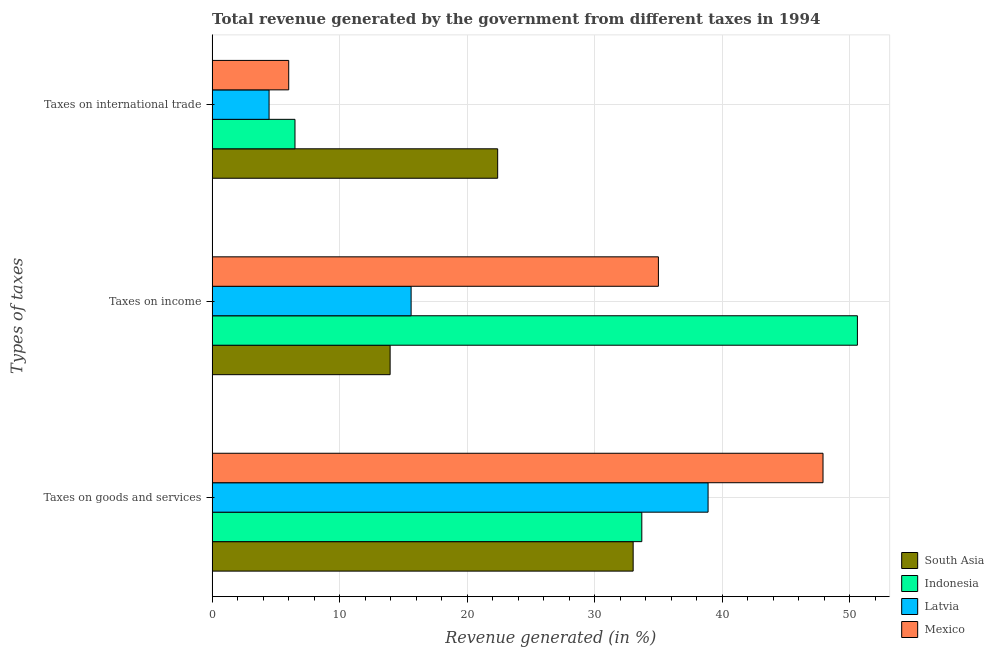How many different coloured bars are there?
Offer a very short reply. 4. How many bars are there on the 3rd tick from the top?
Your answer should be very brief. 4. What is the label of the 1st group of bars from the top?
Provide a succinct answer. Taxes on international trade. What is the percentage of revenue generated by tax on international trade in Latvia?
Make the answer very short. 4.46. Across all countries, what is the maximum percentage of revenue generated by tax on international trade?
Make the answer very short. 22.39. Across all countries, what is the minimum percentage of revenue generated by tax on international trade?
Keep it short and to the point. 4.46. In which country was the percentage of revenue generated by tax on international trade minimum?
Your response must be concise. Latvia. What is the total percentage of revenue generated by taxes on goods and services in the graph?
Keep it short and to the point. 153.46. What is the difference between the percentage of revenue generated by taxes on goods and services in Latvia and that in Indonesia?
Your response must be concise. 5.19. What is the difference between the percentage of revenue generated by taxes on income in Mexico and the percentage of revenue generated by taxes on goods and services in Latvia?
Your answer should be compact. -3.89. What is the average percentage of revenue generated by tax on international trade per country?
Your answer should be very brief. 9.84. What is the difference between the percentage of revenue generated by taxes on goods and services and percentage of revenue generated by taxes on income in Indonesia?
Give a very brief answer. -16.9. In how many countries, is the percentage of revenue generated by taxes on goods and services greater than 40 %?
Ensure brevity in your answer.  1. What is the ratio of the percentage of revenue generated by tax on international trade in Indonesia to that in Mexico?
Keep it short and to the point. 1.08. Is the percentage of revenue generated by tax on international trade in Latvia less than that in Mexico?
Offer a very short reply. Yes. Is the difference between the percentage of revenue generated by taxes on income in Latvia and South Asia greater than the difference between the percentage of revenue generated by taxes on goods and services in Latvia and South Asia?
Keep it short and to the point. No. What is the difference between the highest and the second highest percentage of revenue generated by tax on international trade?
Your answer should be very brief. 15.89. What is the difference between the highest and the lowest percentage of revenue generated by taxes on goods and services?
Ensure brevity in your answer.  14.88. In how many countries, is the percentage of revenue generated by taxes on income greater than the average percentage of revenue generated by taxes on income taken over all countries?
Provide a short and direct response. 2. What does the 3rd bar from the top in Taxes on international trade represents?
Provide a short and direct response. Indonesia. How many bars are there?
Your answer should be compact. 12. Are all the bars in the graph horizontal?
Your answer should be compact. Yes. How many countries are there in the graph?
Your answer should be very brief. 4. What is the difference between two consecutive major ticks on the X-axis?
Offer a terse response. 10. Are the values on the major ticks of X-axis written in scientific E-notation?
Offer a very short reply. No. Does the graph contain any zero values?
Ensure brevity in your answer.  No. Does the graph contain grids?
Your answer should be very brief. Yes. Where does the legend appear in the graph?
Your answer should be compact. Bottom right. How are the legend labels stacked?
Provide a succinct answer. Vertical. What is the title of the graph?
Your answer should be very brief. Total revenue generated by the government from different taxes in 1994. Does "Lower middle income" appear as one of the legend labels in the graph?
Ensure brevity in your answer.  No. What is the label or title of the X-axis?
Keep it short and to the point. Revenue generated (in %). What is the label or title of the Y-axis?
Ensure brevity in your answer.  Types of taxes. What is the Revenue generated (in %) in South Asia in Taxes on goods and services?
Your answer should be very brief. 33.01. What is the Revenue generated (in %) of Indonesia in Taxes on goods and services?
Provide a succinct answer. 33.68. What is the Revenue generated (in %) in Latvia in Taxes on goods and services?
Your answer should be compact. 38.88. What is the Revenue generated (in %) in Mexico in Taxes on goods and services?
Provide a short and direct response. 47.89. What is the Revenue generated (in %) in South Asia in Taxes on income?
Your answer should be compact. 13.95. What is the Revenue generated (in %) in Indonesia in Taxes on income?
Give a very brief answer. 50.58. What is the Revenue generated (in %) of Latvia in Taxes on income?
Your answer should be compact. 15.6. What is the Revenue generated (in %) of Mexico in Taxes on income?
Your answer should be very brief. 34.98. What is the Revenue generated (in %) of South Asia in Taxes on international trade?
Offer a very short reply. 22.39. What is the Revenue generated (in %) in Indonesia in Taxes on international trade?
Keep it short and to the point. 6.5. What is the Revenue generated (in %) of Latvia in Taxes on international trade?
Your answer should be compact. 4.46. What is the Revenue generated (in %) in Mexico in Taxes on international trade?
Ensure brevity in your answer.  6. Across all Types of taxes, what is the maximum Revenue generated (in %) in South Asia?
Offer a very short reply. 33.01. Across all Types of taxes, what is the maximum Revenue generated (in %) of Indonesia?
Provide a succinct answer. 50.58. Across all Types of taxes, what is the maximum Revenue generated (in %) in Latvia?
Ensure brevity in your answer.  38.88. Across all Types of taxes, what is the maximum Revenue generated (in %) of Mexico?
Your response must be concise. 47.89. Across all Types of taxes, what is the minimum Revenue generated (in %) in South Asia?
Give a very brief answer. 13.95. Across all Types of taxes, what is the minimum Revenue generated (in %) of Indonesia?
Your answer should be compact. 6.5. Across all Types of taxes, what is the minimum Revenue generated (in %) in Latvia?
Your response must be concise. 4.46. Across all Types of taxes, what is the minimum Revenue generated (in %) in Mexico?
Your answer should be very brief. 6. What is the total Revenue generated (in %) in South Asia in the graph?
Make the answer very short. 69.34. What is the total Revenue generated (in %) of Indonesia in the graph?
Your response must be concise. 90.76. What is the total Revenue generated (in %) in Latvia in the graph?
Provide a succinct answer. 58.94. What is the total Revenue generated (in %) in Mexico in the graph?
Keep it short and to the point. 88.88. What is the difference between the Revenue generated (in %) of South Asia in Taxes on goods and services and that in Taxes on income?
Your answer should be compact. 19.05. What is the difference between the Revenue generated (in %) of Indonesia in Taxes on goods and services and that in Taxes on income?
Make the answer very short. -16.9. What is the difference between the Revenue generated (in %) of Latvia in Taxes on goods and services and that in Taxes on income?
Ensure brevity in your answer.  23.28. What is the difference between the Revenue generated (in %) in Mexico in Taxes on goods and services and that in Taxes on income?
Keep it short and to the point. 12.9. What is the difference between the Revenue generated (in %) of South Asia in Taxes on goods and services and that in Taxes on international trade?
Make the answer very short. 10.62. What is the difference between the Revenue generated (in %) of Indonesia in Taxes on goods and services and that in Taxes on international trade?
Your answer should be very brief. 27.19. What is the difference between the Revenue generated (in %) in Latvia in Taxes on goods and services and that in Taxes on international trade?
Provide a short and direct response. 34.41. What is the difference between the Revenue generated (in %) of Mexico in Taxes on goods and services and that in Taxes on international trade?
Your response must be concise. 41.88. What is the difference between the Revenue generated (in %) of South Asia in Taxes on income and that in Taxes on international trade?
Make the answer very short. -8.43. What is the difference between the Revenue generated (in %) of Indonesia in Taxes on income and that in Taxes on international trade?
Your response must be concise. 44.09. What is the difference between the Revenue generated (in %) of Latvia in Taxes on income and that in Taxes on international trade?
Your answer should be very brief. 11.14. What is the difference between the Revenue generated (in %) of Mexico in Taxes on income and that in Taxes on international trade?
Give a very brief answer. 28.98. What is the difference between the Revenue generated (in %) in South Asia in Taxes on goods and services and the Revenue generated (in %) in Indonesia in Taxes on income?
Ensure brevity in your answer.  -17.58. What is the difference between the Revenue generated (in %) in South Asia in Taxes on goods and services and the Revenue generated (in %) in Latvia in Taxes on income?
Provide a succinct answer. 17.41. What is the difference between the Revenue generated (in %) in South Asia in Taxes on goods and services and the Revenue generated (in %) in Mexico in Taxes on income?
Your answer should be very brief. -1.98. What is the difference between the Revenue generated (in %) of Indonesia in Taxes on goods and services and the Revenue generated (in %) of Latvia in Taxes on income?
Your answer should be compact. 18.09. What is the difference between the Revenue generated (in %) of Indonesia in Taxes on goods and services and the Revenue generated (in %) of Mexico in Taxes on income?
Provide a succinct answer. -1.3. What is the difference between the Revenue generated (in %) of Latvia in Taxes on goods and services and the Revenue generated (in %) of Mexico in Taxes on income?
Provide a succinct answer. 3.89. What is the difference between the Revenue generated (in %) of South Asia in Taxes on goods and services and the Revenue generated (in %) of Indonesia in Taxes on international trade?
Make the answer very short. 26.51. What is the difference between the Revenue generated (in %) in South Asia in Taxes on goods and services and the Revenue generated (in %) in Latvia in Taxes on international trade?
Give a very brief answer. 28.54. What is the difference between the Revenue generated (in %) of South Asia in Taxes on goods and services and the Revenue generated (in %) of Mexico in Taxes on international trade?
Offer a terse response. 27. What is the difference between the Revenue generated (in %) of Indonesia in Taxes on goods and services and the Revenue generated (in %) of Latvia in Taxes on international trade?
Your answer should be compact. 29.22. What is the difference between the Revenue generated (in %) in Indonesia in Taxes on goods and services and the Revenue generated (in %) in Mexico in Taxes on international trade?
Give a very brief answer. 27.68. What is the difference between the Revenue generated (in %) of Latvia in Taxes on goods and services and the Revenue generated (in %) of Mexico in Taxes on international trade?
Give a very brief answer. 32.87. What is the difference between the Revenue generated (in %) in South Asia in Taxes on income and the Revenue generated (in %) in Indonesia in Taxes on international trade?
Make the answer very short. 7.46. What is the difference between the Revenue generated (in %) in South Asia in Taxes on income and the Revenue generated (in %) in Latvia in Taxes on international trade?
Your response must be concise. 9.49. What is the difference between the Revenue generated (in %) of South Asia in Taxes on income and the Revenue generated (in %) of Mexico in Taxes on international trade?
Give a very brief answer. 7.95. What is the difference between the Revenue generated (in %) in Indonesia in Taxes on income and the Revenue generated (in %) in Latvia in Taxes on international trade?
Keep it short and to the point. 46.12. What is the difference between the Revenue generated (in %) in Indonesia in Taxes on income and the Revenue generated (in %) in Mexico in Taxes on international trade?
Your answer should be compact. 44.58. What is the difference between the Revenue generated (in %) in Latvia in Taxes on income and the Revenue generated (in %) in Mexico in Taxes on international trade?
Your answer should be very brief. 9.59. What is the average Revenue generated (in %) of South Asia per Types of taxes?
Offer a very short reply. 23.11. What is the average Revenue generated (in %) of Indonesia per Types of taxes?
Give a very brief answer. 30.25. What is the average Revenue generated (in %) of Latvia per Types of taxes?
Offer a terse response. 19.65. What is the average Revenue generated (in %) in Mexico per Types of taxes?
Your response must be concise. 29.63. What is the difference between the Revenue generated (in %) of South Asia and Revenue generated (in %) of Indonesia in Taxes on goods and services?
Ensure brevity in your answer.  -0.68. What is the difference between the Revenue generated (in %) in South Asia and Revenue generated (in %) in Latvia in Taxes on goods and services?
Offer a terse response. -5.87. What is the difference between the Revenue generated (in %) of South Asia and Revenue generated (in %) of Mexico in Taxes on goods and services?
Ensure brevity in your answer.  -14.88. What is the difference between the Revenue generated (in %) in Indonesia and Revenue generated (in %) in Latvia in Taxes on goods and services?
Your answer should be compact. -5.19. What is the difference between the Revenue generated (in %) in Indonesia and Revenue generated (in %) in Mexico in Taxes on goods and services?
Keep it short and to the point. -14.2. What is the difference between the Revenue generated (in %) of Latvia and Revenue generated (in %) of Mexico in Taxes on goods and services?
Make the answer very short. -9.01. What is the difference between the Revenue generated (in %) in South Asia and Revenue generated (in %) in Indonesia in Taxes on income?
Ensure brevity in your answer.  -36.63. What is the difference between the Revenue generated (in %) in South Asia and Revenue generated (in %) in Latvia in Taxes on income?
Keep it short and to the point. -1.65. What is the difference between the Revenue generated (in %) in South Asia and Revenue generated (in %) in Mexico in Taxes on income?
Your answer should be compact. -21.03. What is the difference between the Revenue generated (in %) of Indonesia and Revenue generated (in %) of Latvia in Taxes on income?
Ensure brevity in your answer.  34.98. What is the difference between the Revenue generated (in %) of Indonesia and Revenue generated (in %) of Mexico in Taxes on income?
Your answer should be very brief. 15.6. What is the difference between the Revenue generated (in %) in Latvia and Revenue generated (in %) in Mexico in Taxes on income?
Give a very brief answer. -19.39. What is the difference between the Revenue generated (in %) of South Asia and Revenue generated (in %) of Indonesia in Taxes on international trade?
Your answer should be very brief. 15.89. What is the difference between the Revenue generated (in %) in South Asia and Revenue generated (in %) in Latvia in Taxes on international trade?
Give a very brief answer. 17.92. What is the difference between the Revenue generated (in %) in South Asia and Revenue generated (in %) in Mexico in Taxes on international trade?
Make the answer very short. 16.38. What is the difference between the Revenue generated (in %) in Indonesia and Revenue generated (in %) in Latvia in Taxes on international trade?
Provide a short and direct response. 2.03. What is the difference between the Revenue generated (in %) of Indonesia and Revenue generated (in %) of Mexico in Taxes on international trade?
Ensure brevity in your answer.  0.49. What is the difference between the Revenue generated (in %) in Latvia and Revenue generated (in %) in Mexico in Taxes on international trade?
Give a very brief answer. -1.54. What is the ratio of the Revenue generated (in %) of South Asia in Taxes on goods and services to that in Taxes on income?
Your answer should be very brief. 2.37. What is the ratio of the Revenue generated (in %) in Indonesia in Taxes on goods and services to that in Taxes on income?
Your answer should be compact. 0.67. What is the ratio of the Revenue generated (in %) in Latvia in Taxes on goods and services to that in Taxes on income?
Provide a short and direct response. 2.49. What is the ratio of the Revenue generated (in %) of Mexico in Taxes on goods and services to that in Taxes on income?
Offer a terse response. 1.37. What is the ratio of the Revenue generated (in %) of South Asia in Taxes on goods and services to that in Taxes on international trade?
Make the answer very short. 1.47. What is the ratio of the Revenue generated (in %) of Indonesia in Taxes on goods and services to that in Taxes on international trade?
Your response must be concise. 5.19. What is the ratio of the Revenue generated (in %) of Latvia in Taxes on goods and services to that in Taxes on international trade?
Ensure brevity in your answer.  8.71. What is the ratio of the Revenue generated (in %) of Mexico in Taxes on goods and services to that in Taxes on international trade?
Provide a short and direct response. 7.98. What is the ratio of the Revenue generated (in %) of South Asia in Taxes on income to that in Taxes on international trade?
Keep it short and to the point. 0.62. What is the ratio of the Revenue generated (in %) of Indonesia in Taxes on income to that in Taxes on international trade?
Give a very brief answer. 7.79. What is the ratio of the Revenue generated (in %) in Latvia in Taxes on income to that in Taxes on international trade?
Offer a terse response. 3.49. What is the ratio of the Revenue generated (in %) of Mexico in Taxes on income to that in Taxes on international trade?
Provide a succinct answer. 5.83. What is the difference between the highest and the second highest Revenue generated (in %) of South Asia?
Ensure brevity in your answer.  10.62. What is the difference between the highest and the second highest Revenue generated (in %) in Indonesia?
Provide a succinct answer. 16.9. What is the difference between the highest and the second highest Revenue generated (in %) of Latvia?
Your answer should be very brief. 23.28. What is the difference between the highest and the second highest Revenue generated (in %) of Mexico?
Your response must be concise. 12.9. What is the difference between the highest and the lowest Revenue generated (in %) of South Asia?
Offer a terse response. 19.05. What is the difference between the highest and the lowest Revenue generated (in %) in Indonesia?
Ensure brevity in your answer.  44.09. What is the difference between the highest and the lowest Revenue generated (in %) in Latvia?
Your answer should be compact. 34.41. What is the difference between the highest and the lowest Revenue generated (in %) in Mexico?
Offer a very short reply. 41.88. 